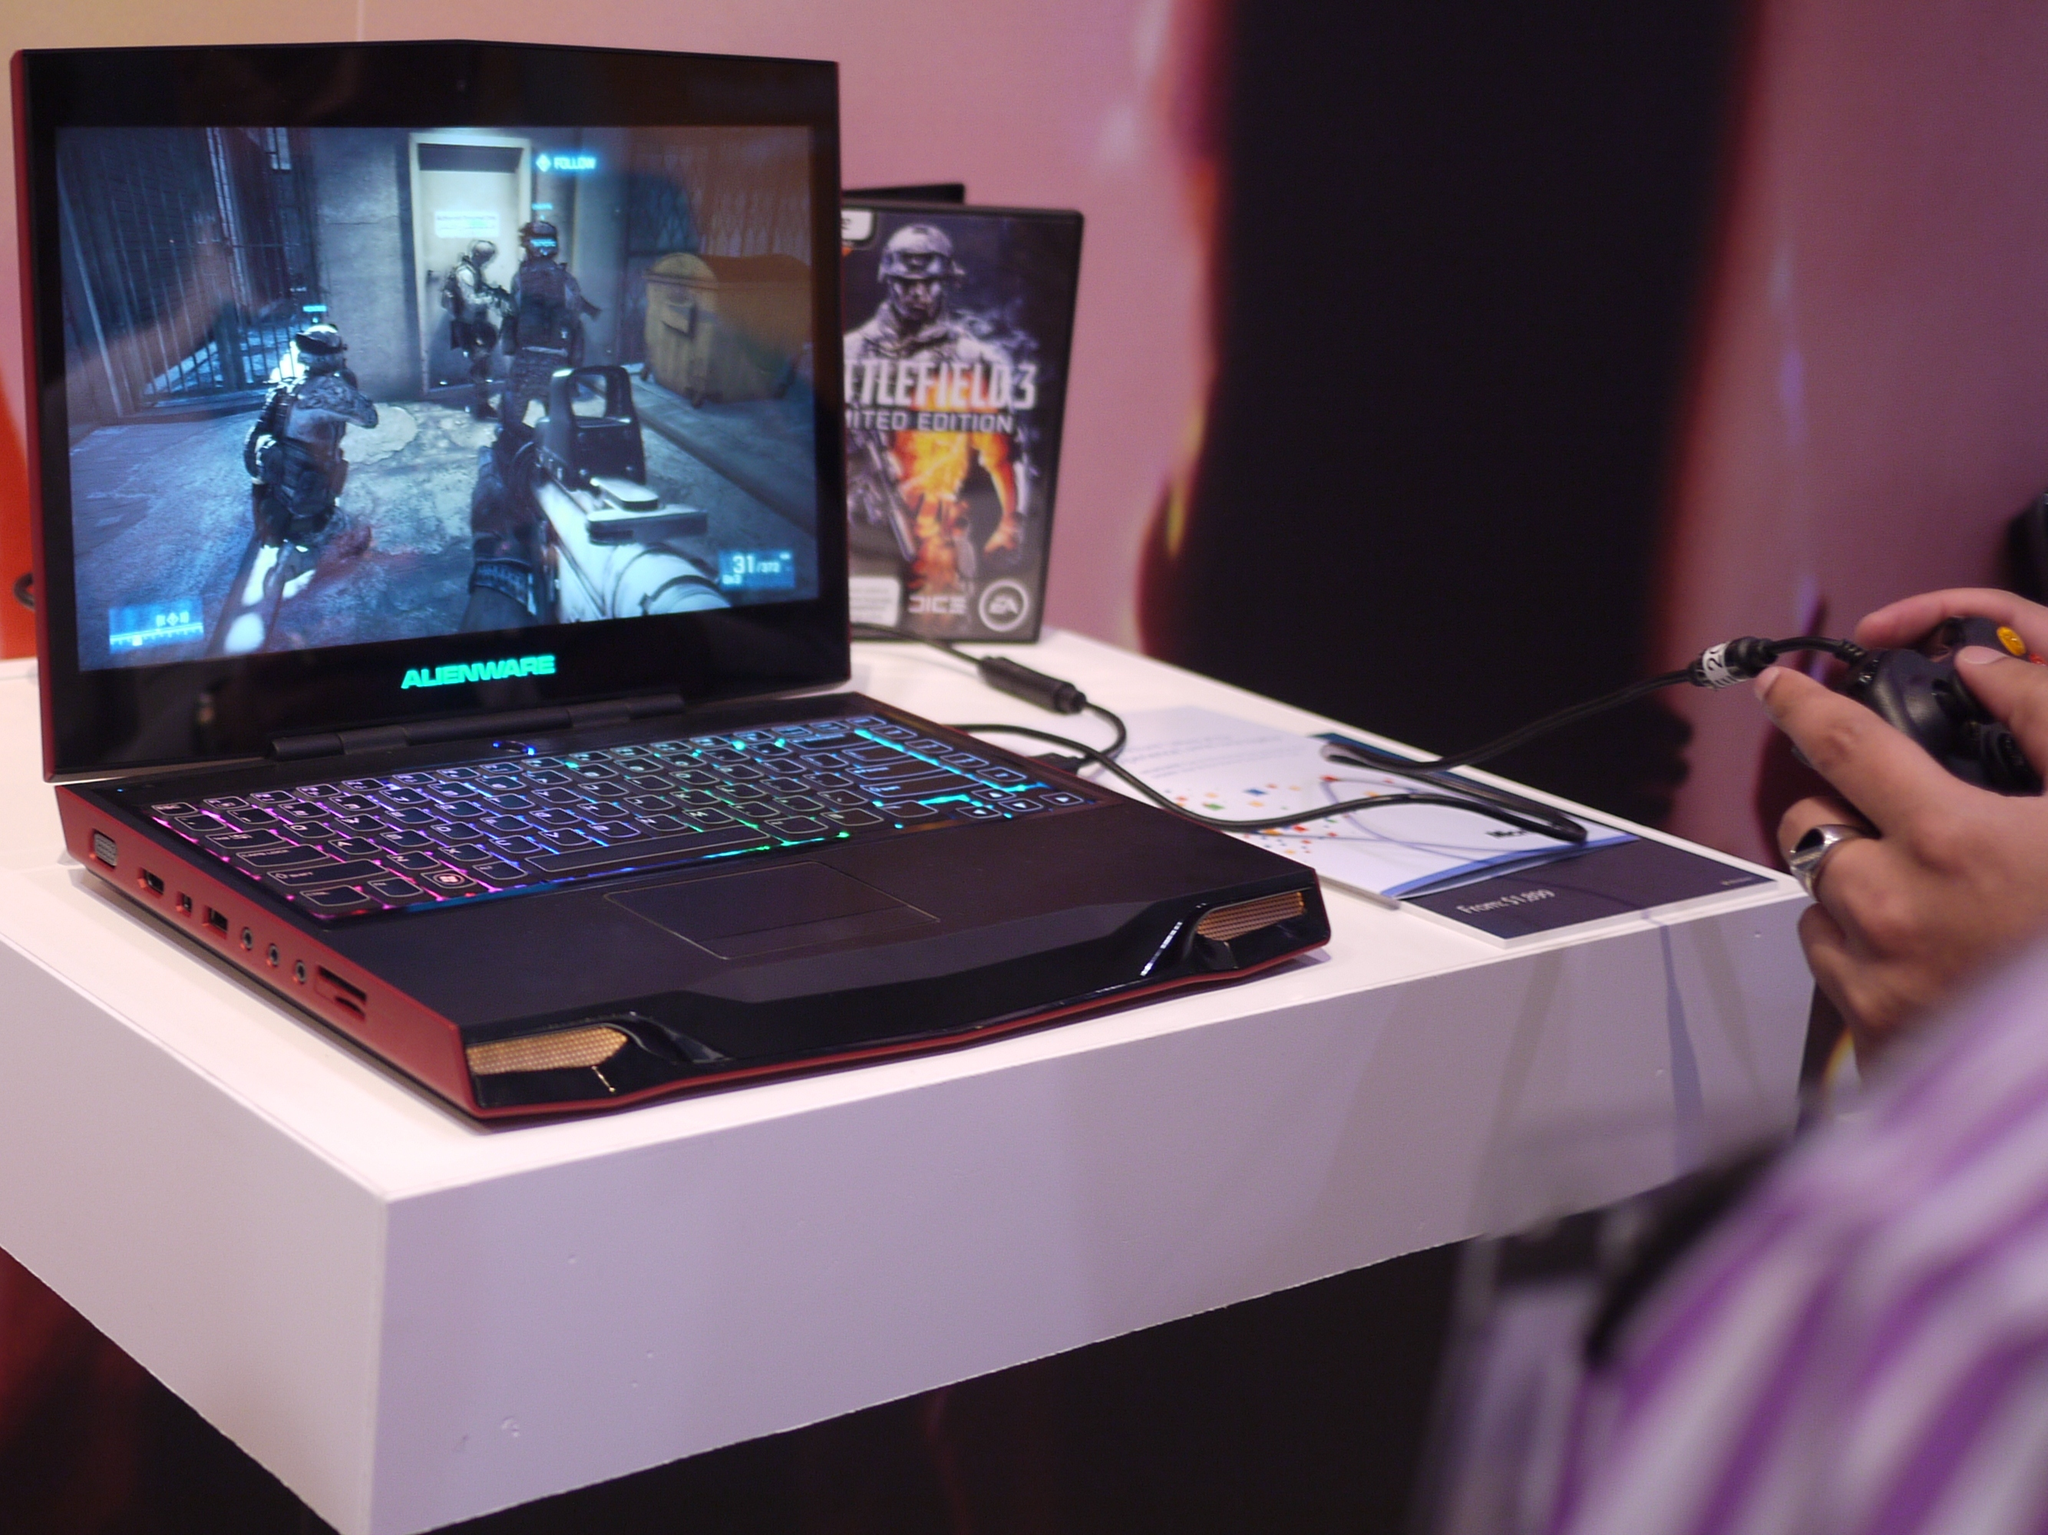Provide a one-sentence caption for the provided image. A game box titled Battlefield 3 sits behind a laptop with a game playing. 